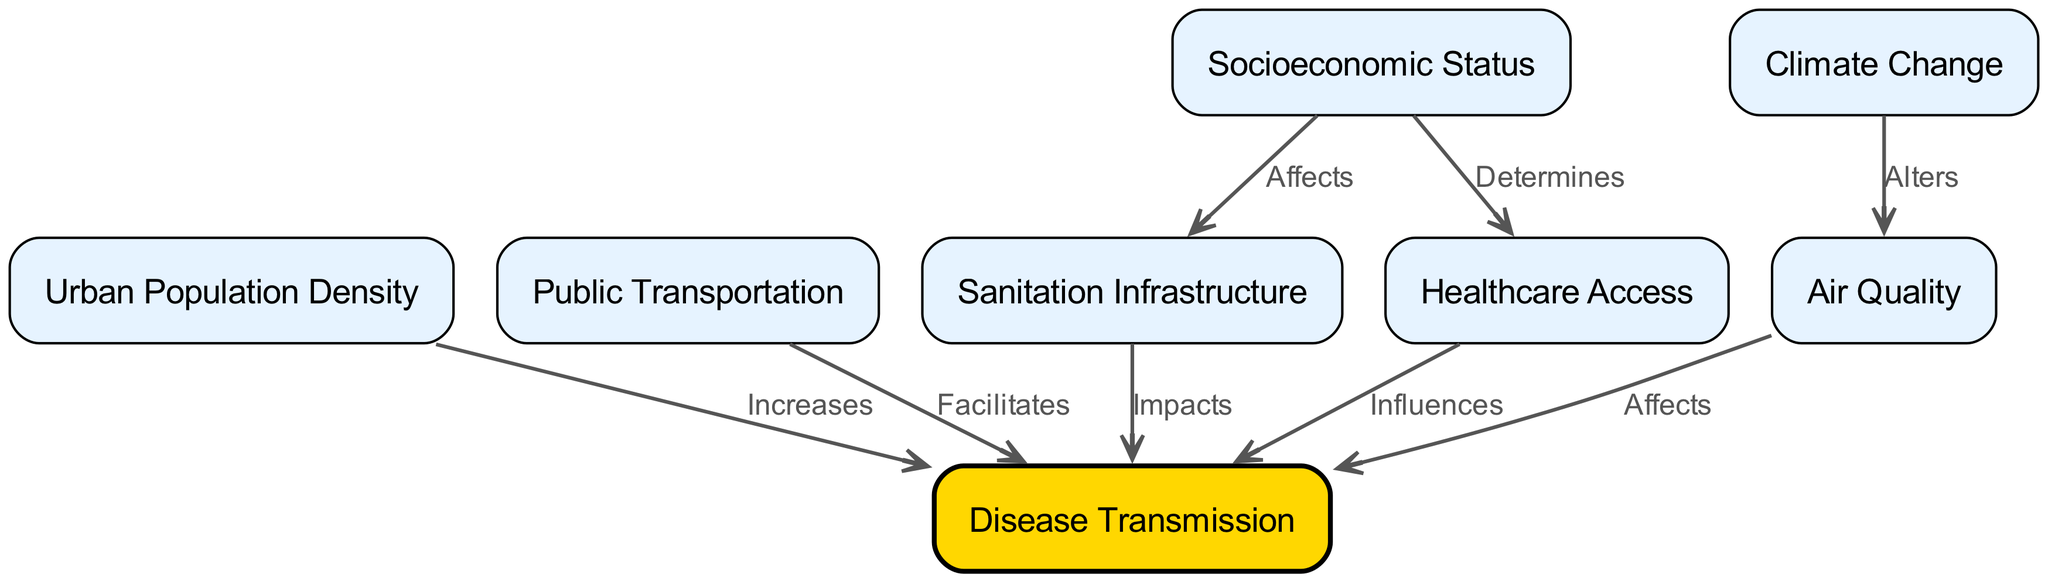What is the total number of nodes in the diagram? Counting the nodes listed in the provided data section of the diagram, we see there are eight distinct nodes regarding urban health factors and disease transmission.
Answer: 8 Which node is influenced by Healthcare Access? Looking at the edges, Healthcare Access (node 4) has a direct edge labeled "Influences" pointing to Disease Transmission (node 8), indicating that it influences this node directly.
Answer: Disease Transmission How many relationships indicate a negative impact on Disease Transmission? The diagram shows multiple edges leading to Disease Transmission (node 8), and all relationships can be interpreted as potential negative impacts on disease transmission, as they explain how various factors contribute to increasing or facilitating it. The total number of these relationships is five.
Answer: 5 Which factors alter Air Quality? The only factor that has a direct relationship altering Air Quality in the diagram is Climate Change (node 6), which indicates its significant impact on air quality, thus affecting disease transmission indirectly.
Answer: Climate Change What effect does Urban Population Density have on Disease Transmission? The edge connecting Urban Population Density (node 1) to Disease Transmission (node 8) has the label "Increases," which clearly conveys that increased urban population density is associated with a rise in disease transmission.
Answer: Increases Which two factors directly determine Healthcare Access? The diagram illustrates that Socioeconomic Status (node 7) directly determines Healthcare Access (node 4). Additionally, there are no other nodes listed that influence this connection.
Answer: Socioeconomic Status Which node has an edge pointing to three different factors? Sanitation Infrastructure (node 3) is the factor that has an edge pointing toward Disease Transmission (node 8) labeled "Impacts," showing a direct influence; however, it only connects to one other node in this specific diagram. Therefore, it does not point toward three values.
Answer: None Which factor affects Sanitation Infrastructure? The diagram does not directly indicate any factors impacting Sanitation Infrastructure (node 3), which implies that while it is influenced by Socioeconomic Status (node 7), this is not explicitly shown in the direct relationships within this diagram.
Answer: None 